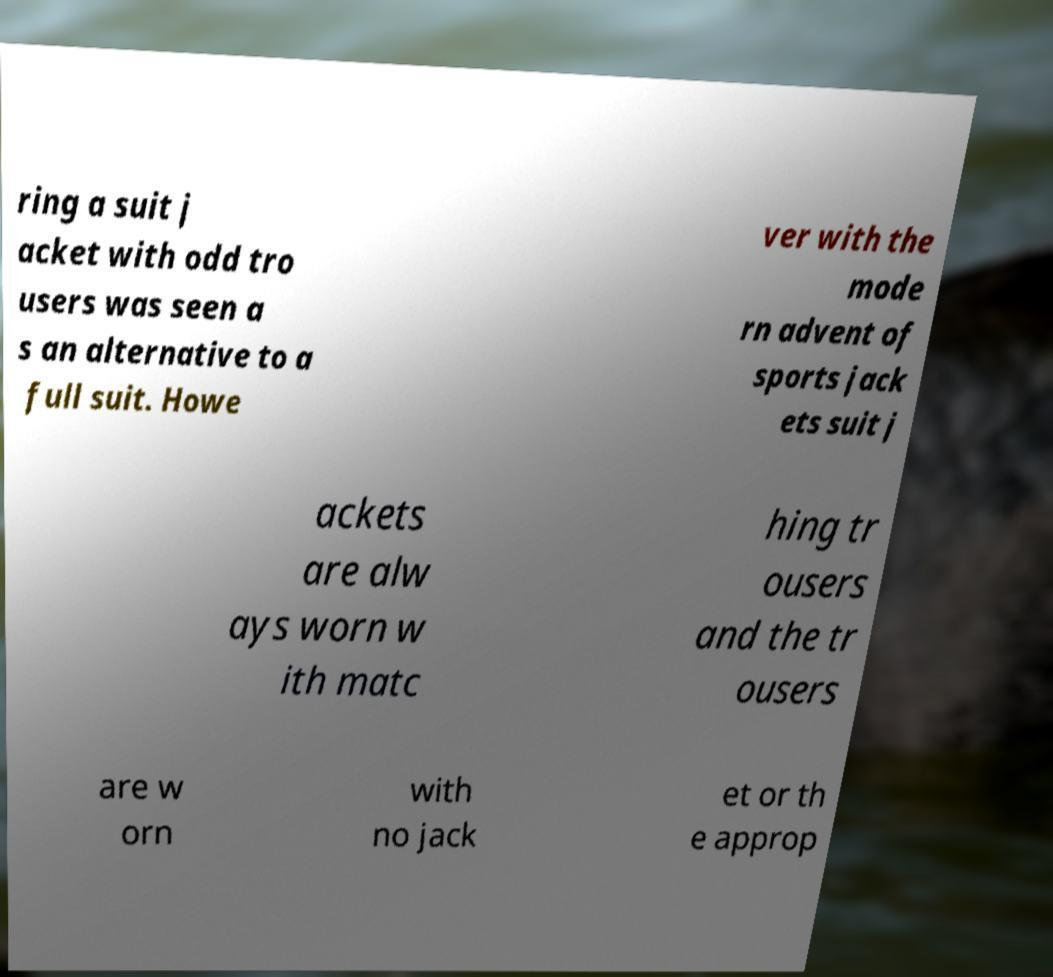Can you accurately transcribe the text from the provided image for me? ring a suit j acket with odd tro users was seen a s an alternative to a full suit. Howe ver with the mode rn advent of sports jack ets suit j ackets are alw ays worn w ith matc hing tr ousers and the tr ousers are w orn with no jack et or th e approp 